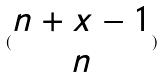Convert formula to latex. <formula><loc_0><loc_0><loc_500><loc_500>( \begin{matrix} n + x - 1 \\ n \end{matrix} )</formula> 